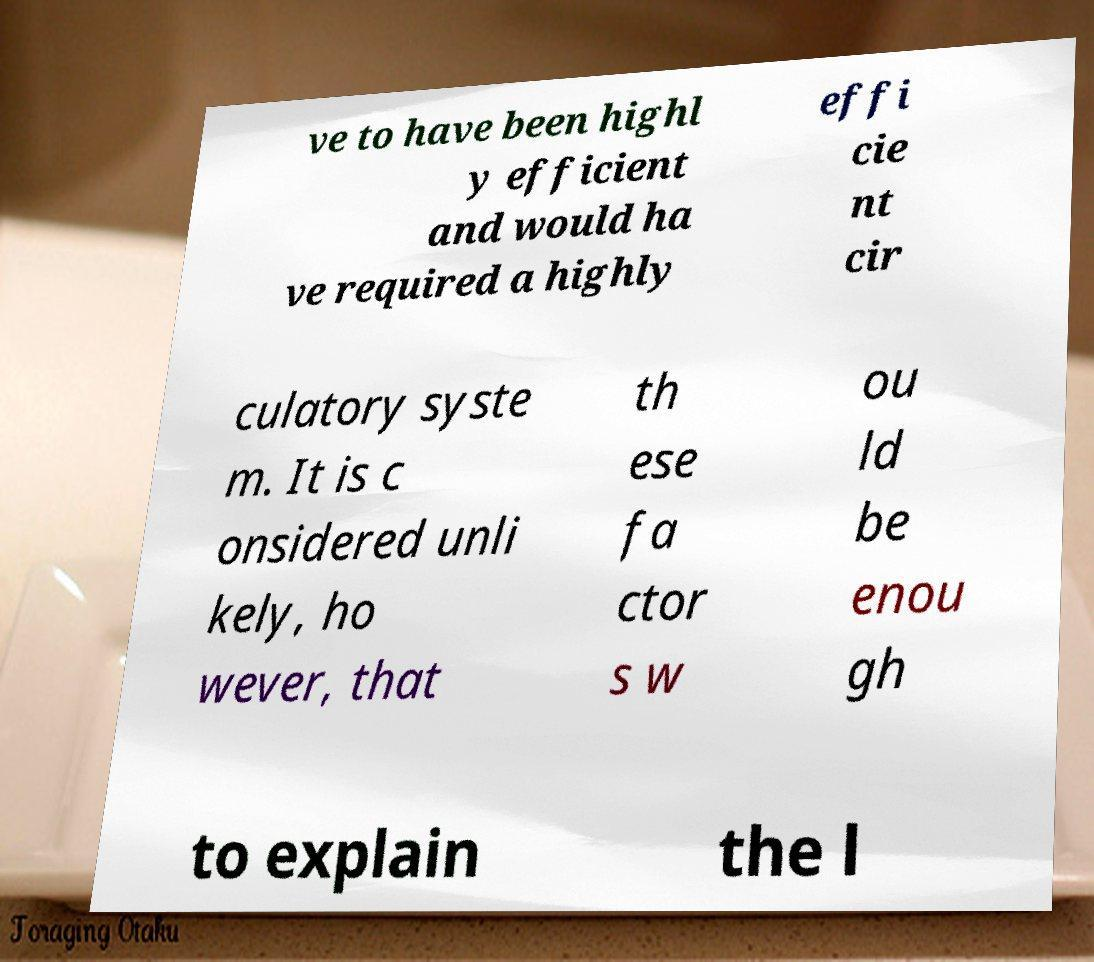For documentation purposes, I need the text within this image transcribed. Could you provide that? ve to have been highl y efficient and would ha ve required a highly effi cie nt cir culatory syste m. It is c onsidered unli kely, ho wever, that th ese fa ctor s w ou ld be enou gh to explain the l 